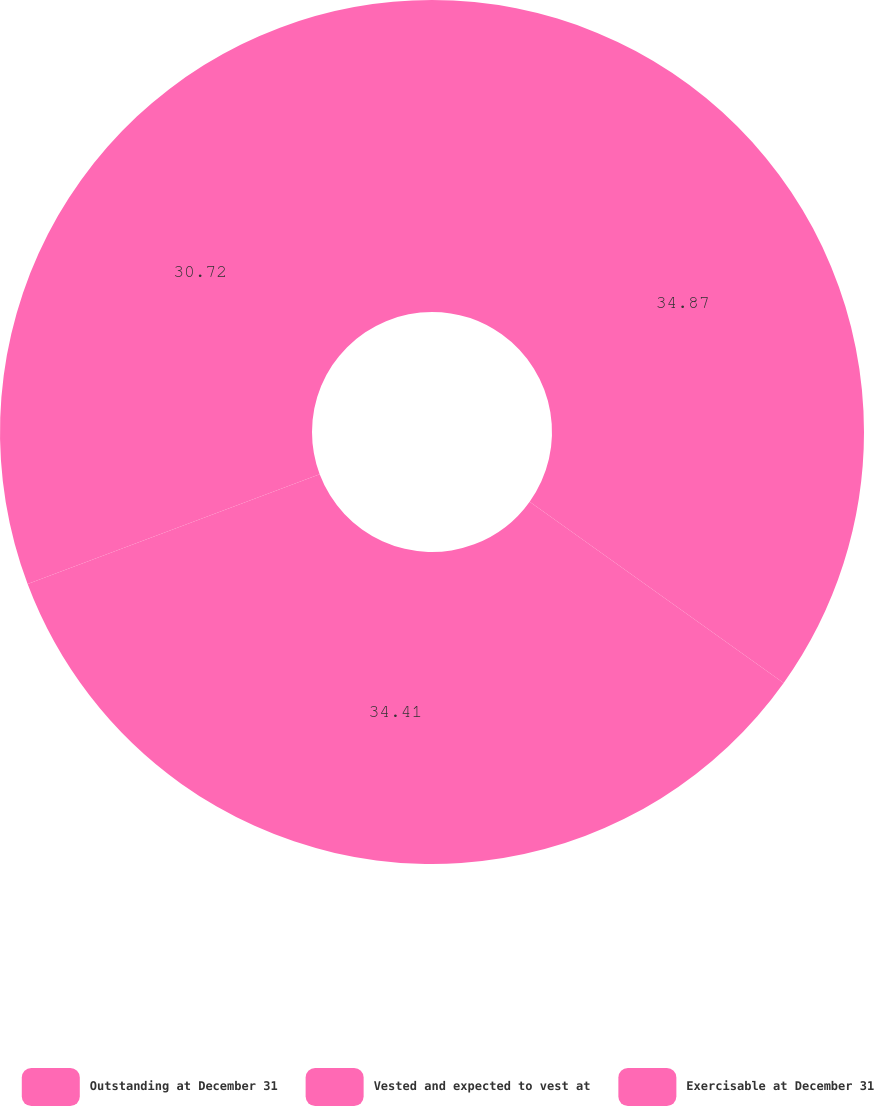Convert chart. <chart><loc_0><loc_0><loc_500><loc_500><pie_chart><fcel>Outstanding at December 31<fcel>Vested and expected to vest at<fcel>Exercisable at December 31<nl><fcel>34.86%<fcel>34.41%<fcel>30.72%<nl></chart> 